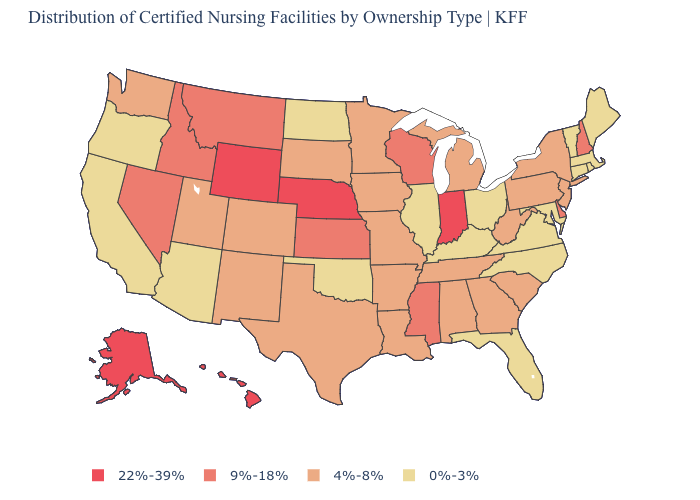Among the states that border Wisconsin , does Illinois have the highest value?
Give a very brief answer. No. Name the states that have a value in the range 0%-3%?
Short answer required. Arizona, California, Connecticut, Florida, Illinois, Kentucky, Maine, Maryland, Massachusetts, North Carolina, North Dakota, Ohio, Oklahoma, Oregon, Rhode Island, Vermont, Virginia. How many symbols are there in the legend?
Be succinct. 4. What is the highest value in the USA?
Write a very short answer. 22%-39%. Does Connecticut have the lowest value in the USA?
Write a very short answer. Yes. Does South Dakota have a higher value than California?
Short answer required. Yes. What is the lowest value in the MidWest?
Keep it brief. 0%-3%. Does the first symbol in the legend represent the smallest category?
Answer briefly. No. Name the states that have a value in the range 9%-18%?
Concise answer only. Delaware, Idaho, Kansas, Mississippi, Montana, Nevada, New Hampshire, Wisconsin. What is the lowest value in the Northeast?
Be succinct. 0%-3%. Which states have the lowest value in the Northeast?
Write a very short answer. Connecticut, Maine, Massachusetts, Rhode Island, Vermont. Does Hawaii have the highest value in the USA?
Concise answer only. Yes. What is the lowest value in the Northeast?
Quick response, please. 0%-3%. Name the states that have a value in the range 4%-8%?
Answer briefly. Alabama, Arkansas, Colorado, Georgia, Iowa, Louisiana, Michigan, Minnesota, Missouri, New Jersey, New Mexico, New York, Pennsylvania, South Carolina, South Dakota, Tennessee, Texas, Utah, Washington, West Virginia. Name the states that have a value in the range 22%-39%?
Quick response, please. Alaska, Hawaii, Indiana, Nebraska, Wyoming. 